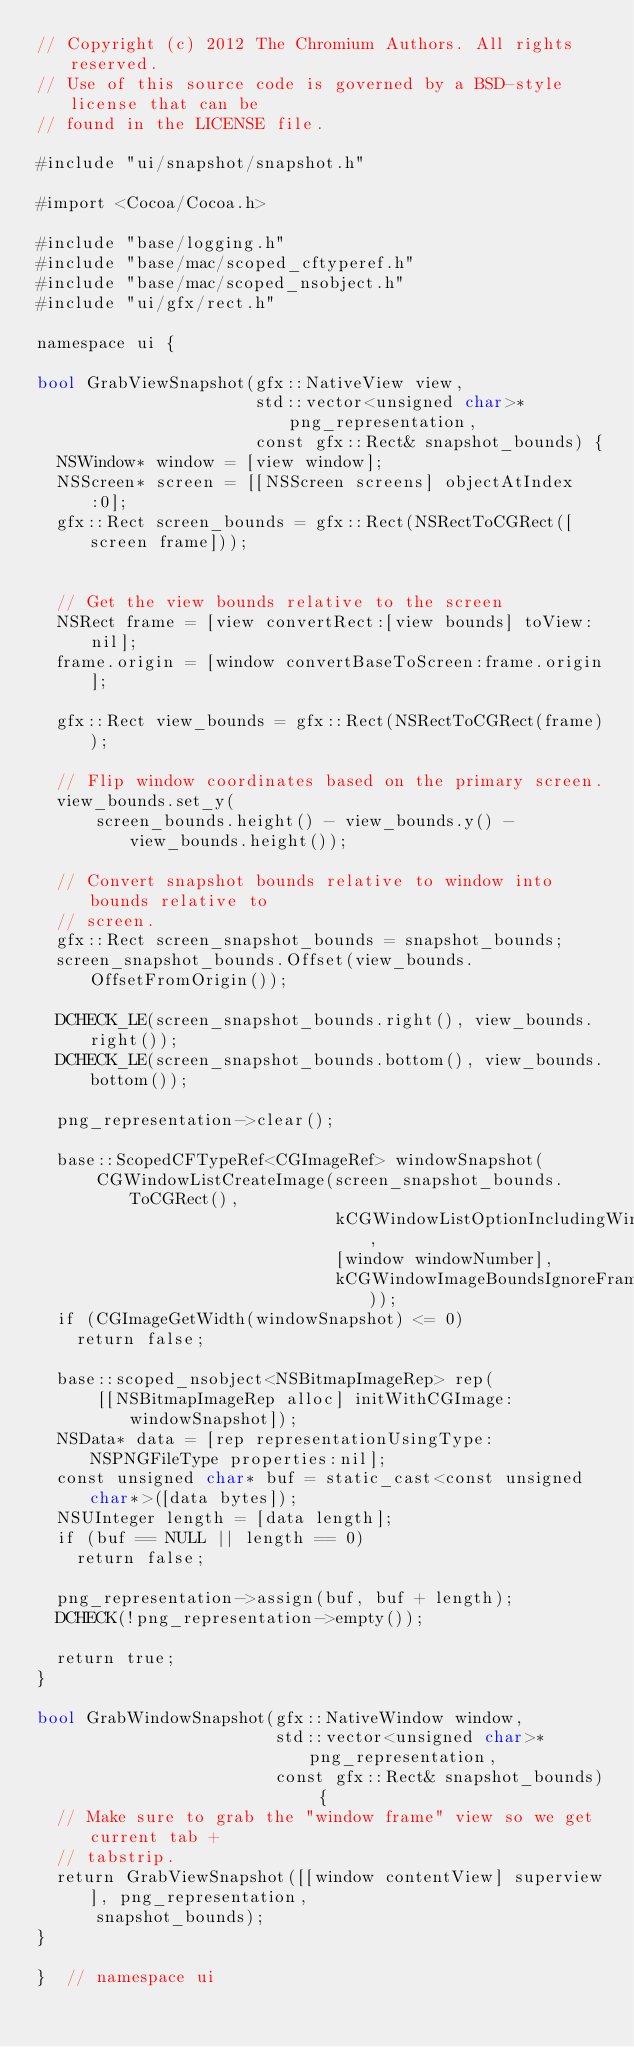<code> <loc_0><loc_0><loc_500><loc_500><_ObjectiveC_>// Copyright (c) 2012 The Chromium Authors. All rights reserved.
// Use of this source code is governed by a BSD-style license that can be
// found in the LICENSE file.

#include "ui/snapshot/snapshot.h"

#import <Cocoa/Cocoa.h>

#include "base/logging.h"
#include "base/mac/scoped_cftyperef.h"
#include "base/mac/scoped_nsobject.h"
#include "ui/gfx/rect.h"

namespace ui {

bool GrabViewSnapshot(gfx::NativeView view,
                      std::vector<unsigned char>* png_representation,
                      const gfx::Rect& snapshot_bounds) {
  NSWindow* window = [view window];
  NSScreen* screen = [[NSScreen screens] objectAtIndex:0];
  gfx::Rect screen_bounds = gfx::Rect(NSRectToCGRect([screen frame]));


  // Get the view bounds relative to the screen
  NSRect frame = [view convertRect:[view bounds] toView:nil];
  frame.origin = [window convertBaseToScreen:frame.origin];

  gfx::Rect view_bounds = gfx::Rect(NSRectToCGRect(frame));

  // Flip window coordinates based on the primary screen.
  view_bounds.set_y(
      screen_bounds.height() - view_bounds.y() - view_bounds.height());

  // Convert snapshot bounds relative to window into bounds relative to
  // screen.
  gfx::Rect screen_snapshot_bounds = snapshot_bounds;
  screen_snapshot_bounds.Offset(view_bounds.OffsetFromOrigin());

  DCHECK_LE(screen_snapshot_bounds.right(), view_bounds.right());
  DCHECK_LE(screen_snapshot_bounds.bottom(), view_bounds.bottom());

  png_representation->clear();

  base::ScopedCFTypeRef<CGImageRef> windowSnapshot(
      CGWindowListCreateImage(screen_snapshot_bounds.ToCGRect(),
                              kCGWindowListOptionIncludingWindow,
                              [window windowNumber],
                              kCGWindowImageBoundsIgnoreFraming));
  if (CGImageGetWidth(windowSnapshot) <= 0)
    return false;

  base::scoped_nsobject<NSBitmapImageRep> rep(
      [[NSBitmapImageRep alloc] initWithCGImage:windowSnapshot]);
  NSData* data = [rep representationUsingType:NSPNGFileType properties:nil];
  const unsigned char* buf = static_cast<const unsigned char*>([data bytes]);
  NSUInteger length = [data length];
  if (buf == NULL || length == 0)
    return false;

  png_representation->assign(buf, buf + length);
  DCHECK(!png_representation->empty());

  return true;
}

bool GrabWindowSnapshot(gfx::NativeWindow window,
                        std::vector<unsigned char>* png_representation,
                        const gfx::Rect& snapshot_bounds) {
  // Make sure to grab the "window frame" view so we get current tab +
  // tabstrip.
  return GrabViewSnapshot([[window contentView] superview], png_representation,
      snapshot_bounds);
}

}  // namespace ui
</code> 